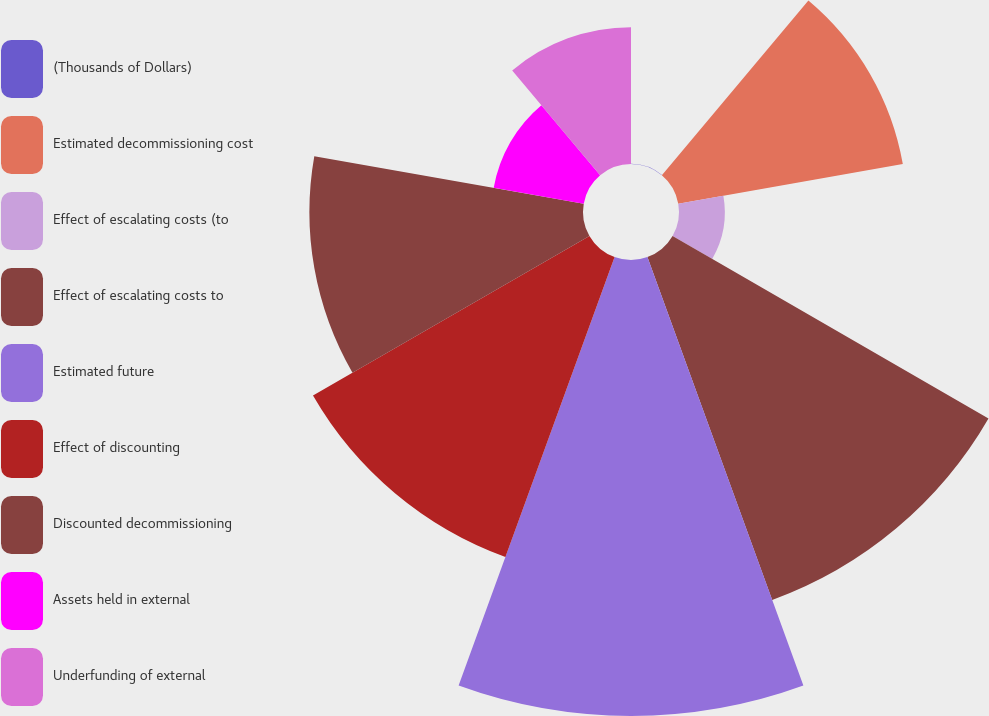Convert chart to OTSL. <chart><loc_0><loc_0><loc_500><loc_500><pie_chart><fcel>(Thousands of Dollars)<fcel>Estimated decommissioning cost<fcel>Effect of escalating costs (to<fcel>Effect of escalating costs to<fcel>Estimated future<fcel>Effect of discounting<fcel>Discounted decommissioning<fcel>Assets held in external<fcel>Underfunding of external<nl><fcel>0.01%<fcel>11.9%<fcel>2.39%<fcel>19.04%<fcel>23.8%<fcel>16.66%<fcel>14.28%<fcel>4.77%<fcel>7.14%<nl></chart> 